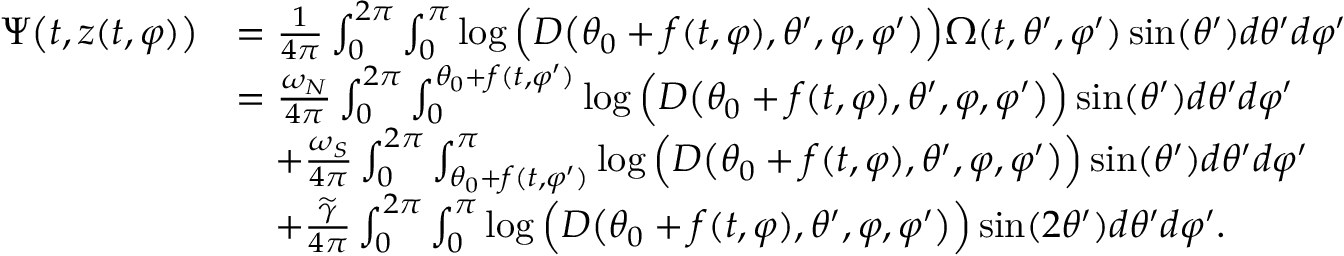Convert formula to latex. <formula><loc_0><loc_0><loc_500><loc_500>\begin{array} { r l } { \Psi \left ( t , z ( t , \varphi ) \right ) } & { = \frac { 1 } { 4 \pi } \int _ { 0 } ^ { 2 \pi } \int _ { 0 } ^ { \pi } \log \left ( D \left ( \theta _ { 0 } + f ( t , \varphi ) , \theta ^ { \prime } , \varphi , \varphi ^ { \prime } \right ) \right ) \Omega ( t , \theta ^ { \prime } , \varphi ^ { \prime } ) \sin ( \theta ^ { \prime } ) d \theta ^ { \prime } d \varphi ^ { \prime } } \\ & { = \frac { \omega _ { N } } { 4 \pi } \int _ { 0 } ^ { 2 \pi } \int _ { 0 } ^ { \theta _ { 0 } + f ( t , \varphi ^ { \prime } ) } \log \left ( D \left ( \theta _ { 0 } + f ( t , \varphi ) , \theta ^ { \prime } , \varphi , \varphi ^ { \prime } \right ) \right ) \sin ( \theta ^ { \prime } ) d \theta ^ { \prime } d \varphi ^ { \prime } } \\ & { \quad + \frac { \omega _ { S } } { 4 \pi } \int _ { 0 } ^ { 2 \pi } \int _ { \theta _ { 0 } + f ( t , \varphi ^ { \prime } ) } ^ { \pi } \log \left ( D \left ( \theta _ { 0 } + f ( t , \varphi ) , \theta ^ { \prime } , \varphi , \varphi ^ { \prime } \right ) \right ) \sin ( \theta ^ { \prime } ) d \theta ^ { \prime } d \varphi ^ { \prime } } \\ & { \quad + \frac { \widetilde { \gamma } } { 4 \pi } \int _ { 0 } ^ { 2 \pi } \int _ { 0 } ^ { \pi } \log \left ( D \left ( \theta _ { 0 } + f ( t , \varphi ) , \theta ^ { \prime } , \varphi , \varphi ^ { \prime } \right ) \right ) \sin ( 2 \theta ^ { \prime } ) d \theta ^ { \prime } d \varphi ^ { \prime } . } \end{array}</formula> 